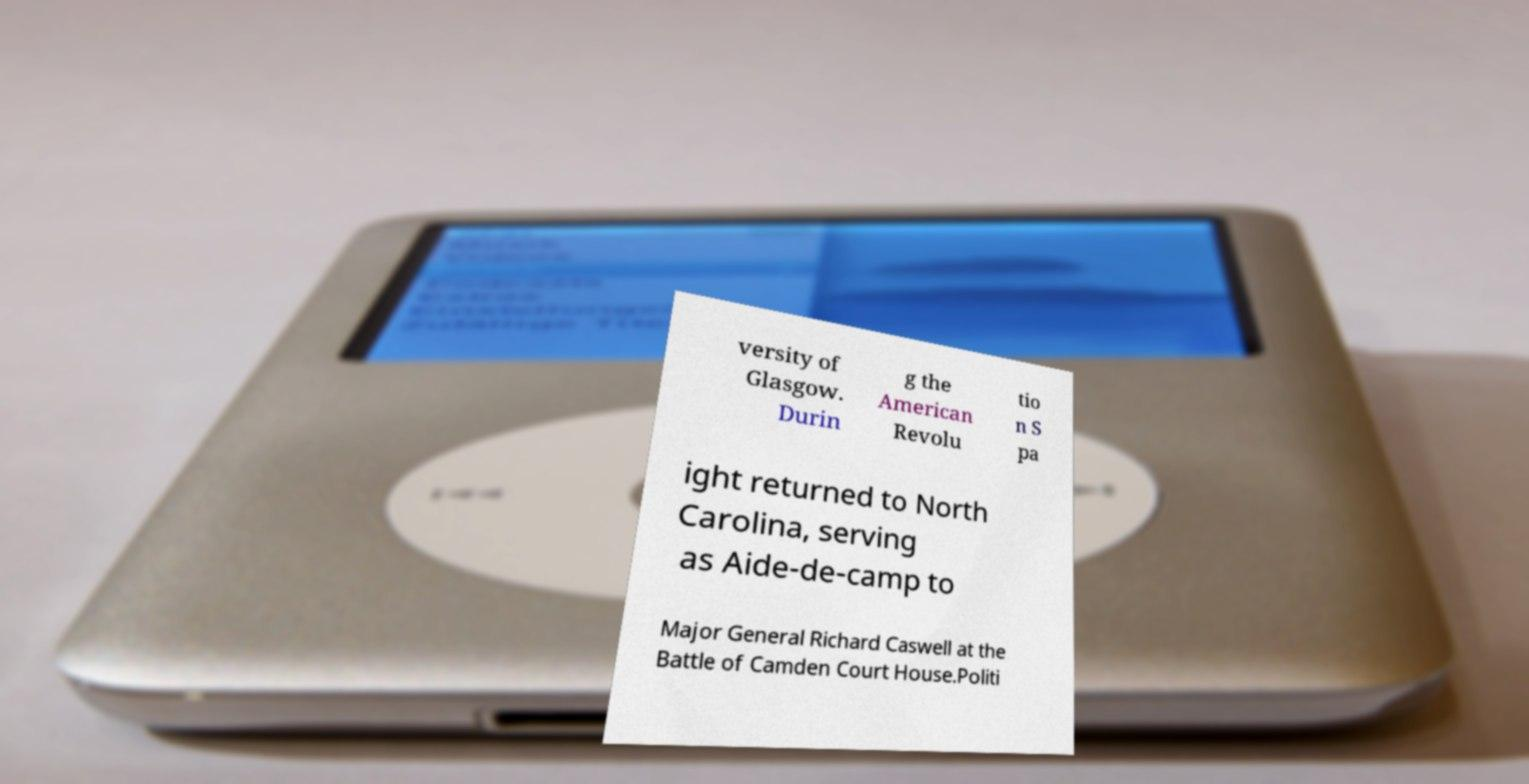For documentation purposes, I need the text within this image transcribed. Could you provide that? versity of Glasgow. Durin g the American Revolu tio n S pa ight returned to North Carolina, serving as Aide-de-camp to Major General Richard Caswell at the Battle of Camden Court House.Politi 